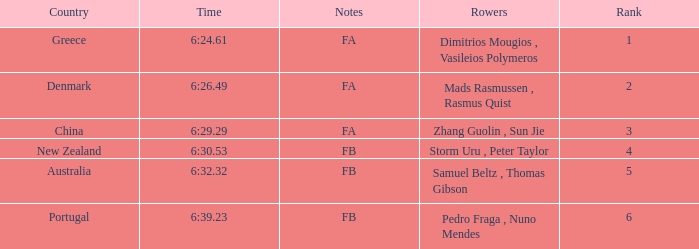What is the standing of the time 6:3 1.0. 